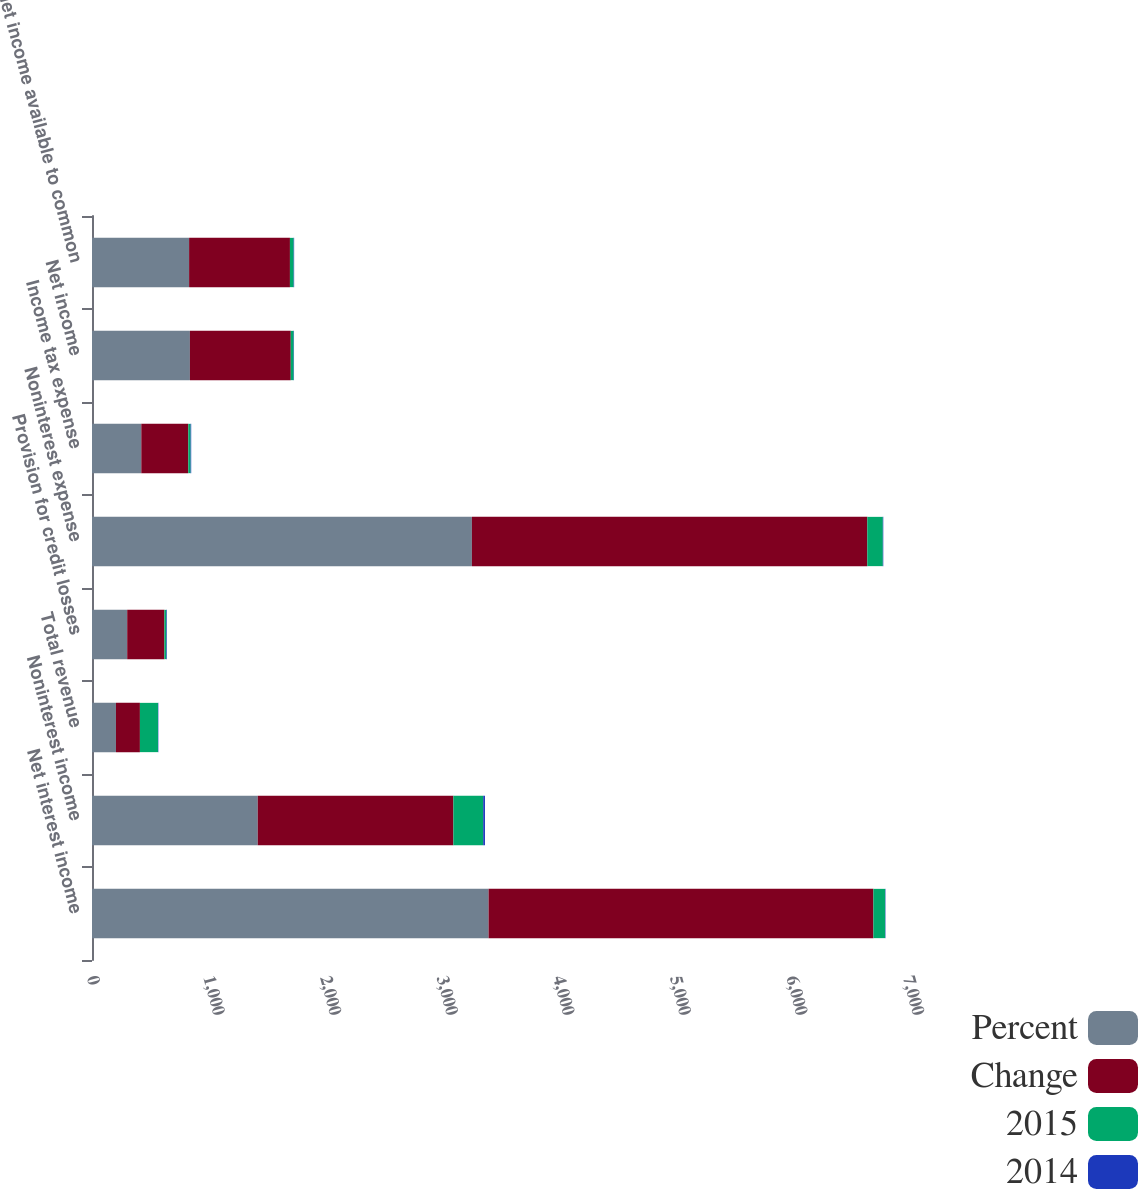Convert chart. <chart><loc_0><loc_0><loc_500><loc_500><stacked_bar_chart><ecel><fcel>Net interest income<fcel>Noninterest income<fcel>Total revenue<fcel>Provision for credit losses<fcel>Noninterest expense<fcel>Income tax expense<fcel>Net income<fcel>Net income available to common<nl><fcel>Percent<fcel>3402<fcel>1422<fcel>205.5<fcel>302<fcel>3259<fcel>423<fcel>840<fcel>833<nl><fcel>Change<fcel>3301<fcel>1678<fcel>205.5<fcel>319<fcel>3392<fcel>403<fcel>865<fcel>865<nl><fcel>2015<fcel>101<fcel>256<fcel>155<fcel>17<fcel>133<fcel>20<fcel>25<fcel>32<nl><fcel>2014<fcel>3<fcel>15<fcel>3<fcel>5<fcel>4<fcel>5<fcel>3<fcel>4<nl></chart> 